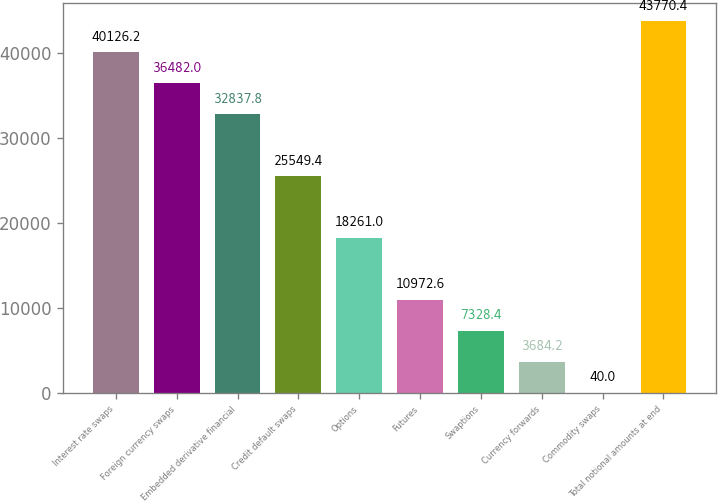Convert chart to OTSL. <chart><loc_0><loc_0><loc_500><loc_500><bar_chart><fcel>Interest rate swaps<fcel>Foreign currency swaps<fcel>Embedded derivative financial<fcel>Credit default swaps<fcel>Options<fcel>Futures<fcel>Swaptions<fcel>Currency forwards<fcel>Commodity swaps<fcel>Total notional amounts at end<nl><fcel>40126.2<fcel>36482<fcel>32837.8<fcel>25549.4<fcel>18261<fcel>10972.6<fcel>7328.4<fcel>3684.2<fcel>40<fcel>43770.4<nl></chart> 